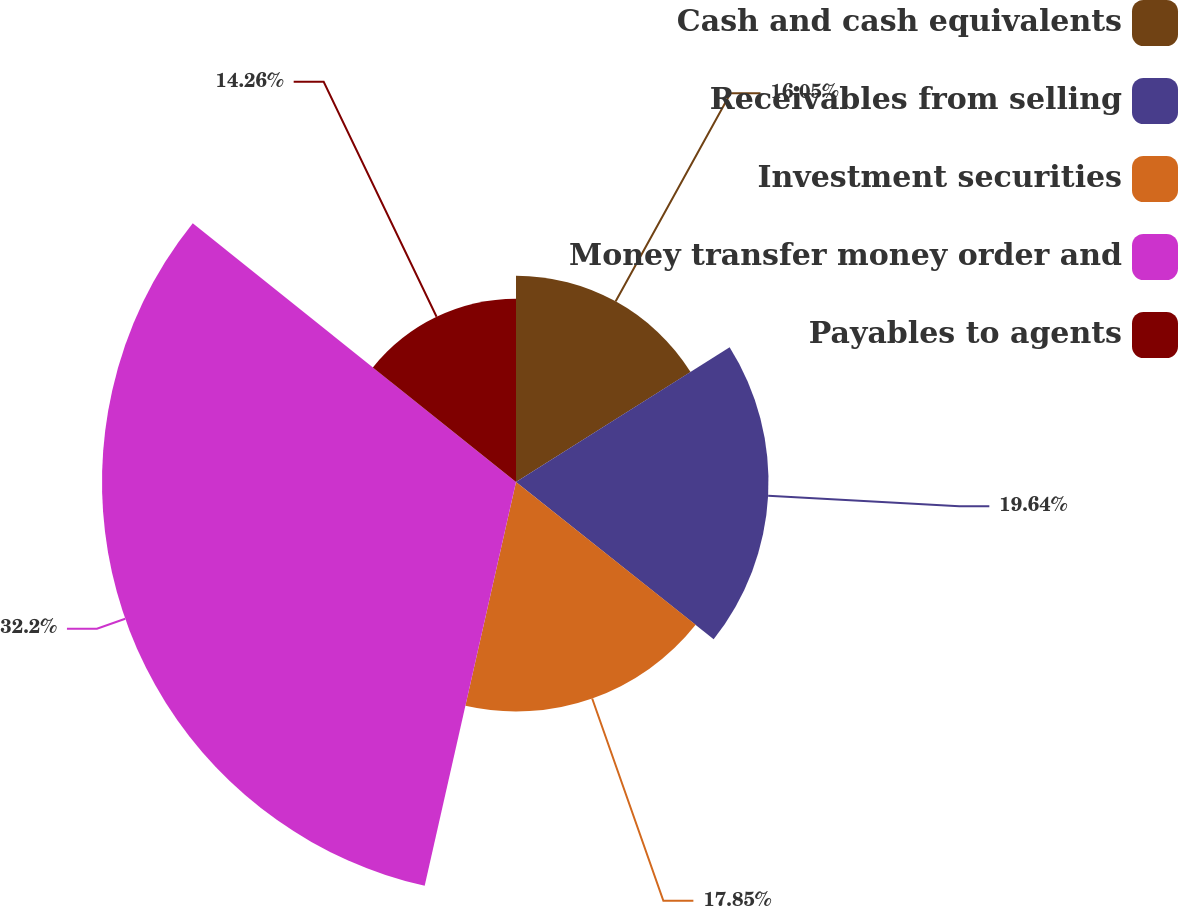Convert chart to OTSL. <chart><loc_0><loc_0><loc_500><loc_500><pie_chart><fcel>Cash and cash equivalents<fcel>Receivables from selling<fcel>Investment securities<fcel>Money transfer money order and<fcel>Payables to agents<nl><fcel>16.05%<fcel>19.64%<fcel>17.85%<fcel>32.2%<fcel>14.26%<nl></chart> 